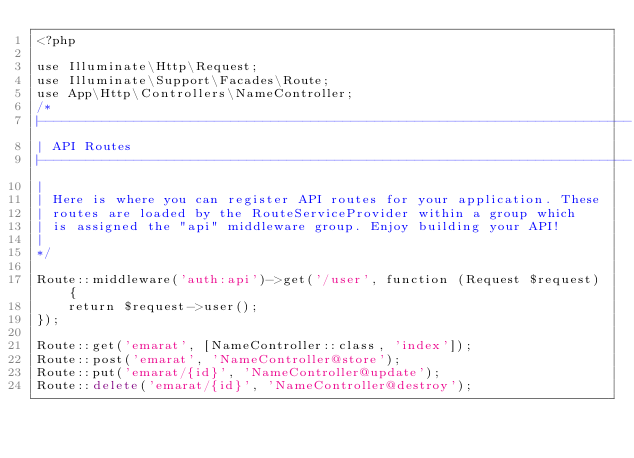<code> <loc_0><loc_0><loc_500><loc_500><_PHP_><?php

use Illuminate\Http\Request;
use Illuminate\Support\Facades\Route;
use App\Http\Controllers\NameController;
/*
|--------------------------------------------------------------------------
| API Routes
|--------------------------------------------------------------------------
|
| Here is where you can register API routes for your application. These
| routes are loaded by the RouteServiceProvider within a group which
| is assigned the "api" middleware group. Enjoy building your API!
|
*/

Route::middleware('auth:api')->get('/user', function (Request $request) {
    return $request->user();
});

Route::get('emarat', [NameController::class, 'index']);
Route::post('emarat', 'NameController@store');
Route::put('emarat/{id}', 'NameController@update');
Route::delete('emarat/{id}', 'NameController@destroy');
</code> 